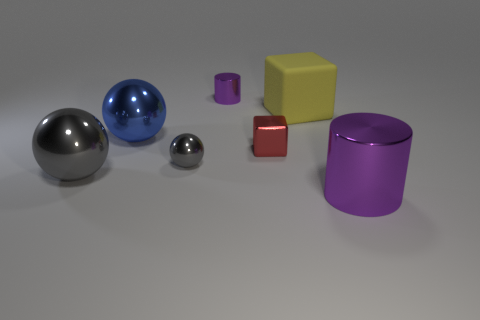What number of things are either purple metal cylinders left of the big yellow matte object or purple shiny cylinders in front of the large cube?
Keep it short and to the point. 2. Are there more small purple metal objects behind the small gray thing than purple things?
Provide a succinct answer. No. How many other objects have the same size as the yellow rubber object?
Ensure brevity in your answer.  3. There is a purple thing right of the large yellow object; does it have the same size as the purple metal cylinder behind the large gray shiny thing?
Keep it short and to the point. No. How big is the shiny thing that is to the left of the large blue ball?
Provide a short and direct response. Large. There is a gray metal thing in front of the tiny gray sphere that is left of the yellow matte cube; what size is it?
Your response must be concise. Large. What material is the blue ball that is the same size as the yellow rubber thing?
Give a very brief answer. Metal. There is a large purple metal cylinder; are there any yellow rubber cubes in front of it?
Give a very brief answer. No. Are there the same number of yellow matte cubes that are in front of the red object and blue rubber cubes?
Make the answer very short. Yes. What shape is the matte thing that is the same size as the blue metallic sphere?
Your answer should be very brief. Cube. 